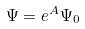<formula> <loc_0><loc_0><loc_500><loc_500>\Psi = e ^ { A } \Psi _ { 0 }</formula> 